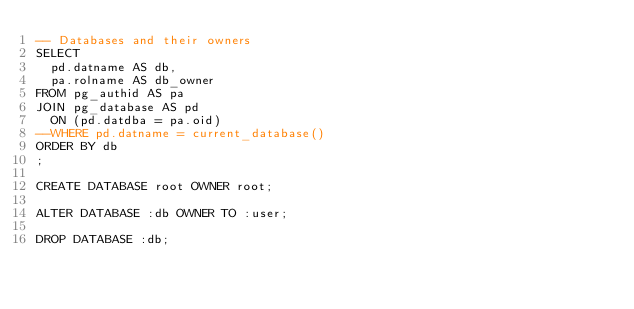<code> <loc_0><loc_0><loc_500><loc_500><_SQL_>-- Databases and their owners
SELECT
  pd.datname AS db,
  pa.rolname AS db_owner
FROM pg_authid AS pa
JOIN pg_database AS pd
  ON (pd.datdba = pa.oid)
--WHERE pd.datname = current_database()
ORDER BY db
;

CREATE DATABASE root OWNER root;

ALTER DATABASE :db OWNER TO :user;

DROP DATABASE :db;</code> 